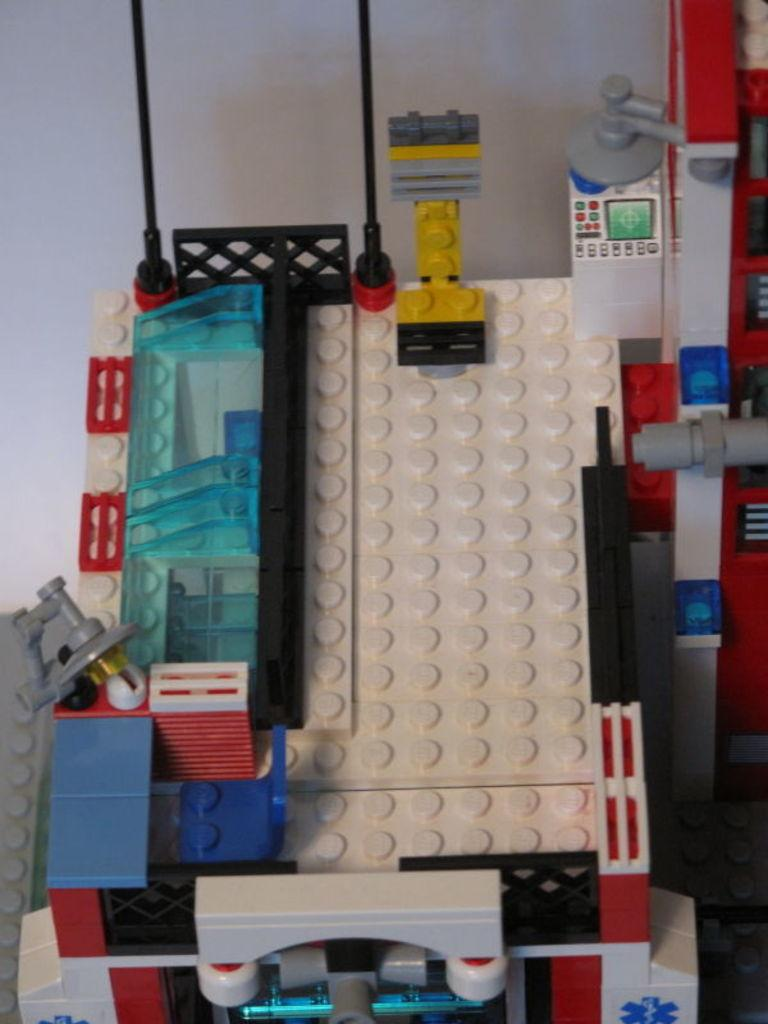What is the main object in the image? There is a toy in the image. What colors can be seen on the toy? The toy has white, blue, and red colors. What is the toy placed on in the image? The toy is placed on a white surface. How many tomatoes are visible in the image? There are no tomatoes present in the image. What type of furniture can be seen in the image? There is no furniture present in the image. 